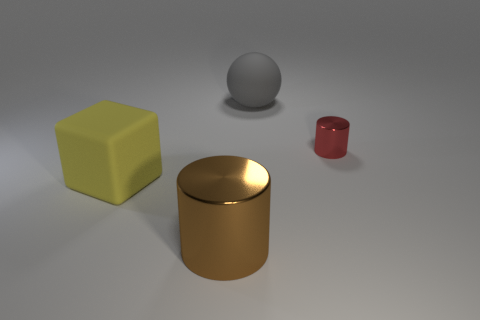Is the size of the matte sphere that is right of the block the same as the large brown metal cylinder?
Keep it short and to the point. Yes. What is the material of the tiny cylinder?
Your answer should be compact. Metal. The metal object that is in front of the block is what color?
Your answer should be compact. Brown. What number of tiny objects are either gray spheres or matte blocks?
Provide a short and direct response. 0. There is a cylinder that is behind the big metal cylinder; is it the same color as the big matte thing behind the matte cube?
Ensure brevity in your answer.  No. How many other objects are the same color as the big sphere?
Offer a very short reply. 0. What number of green objects are small metallic objects or big shiny objects?
Ensure brevity in your answer.  0. Do the tiny thing and the large rubber object that is in front of the red metallic object have the same shape?
Provide a short and direct response. No. The big metallic object has what shape?
Offer a very short reply. Cylinder. There is a brown object that is the same size as the yellow block; what material is it?
Your answer should be compact. Metal. 